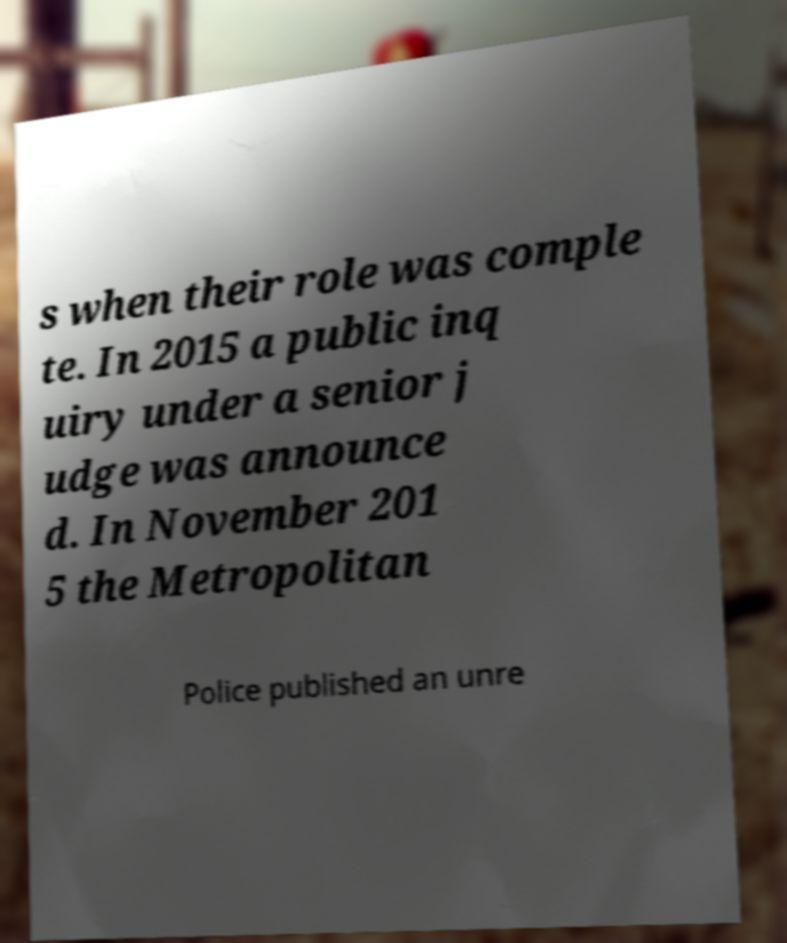Can you accurately transcribe the text from the provided image for me? s when their role was comple te. In 2015 a public inq uiry under a senior j udge was announce d. In November 201 5 the Metropolitan Police published an unre 